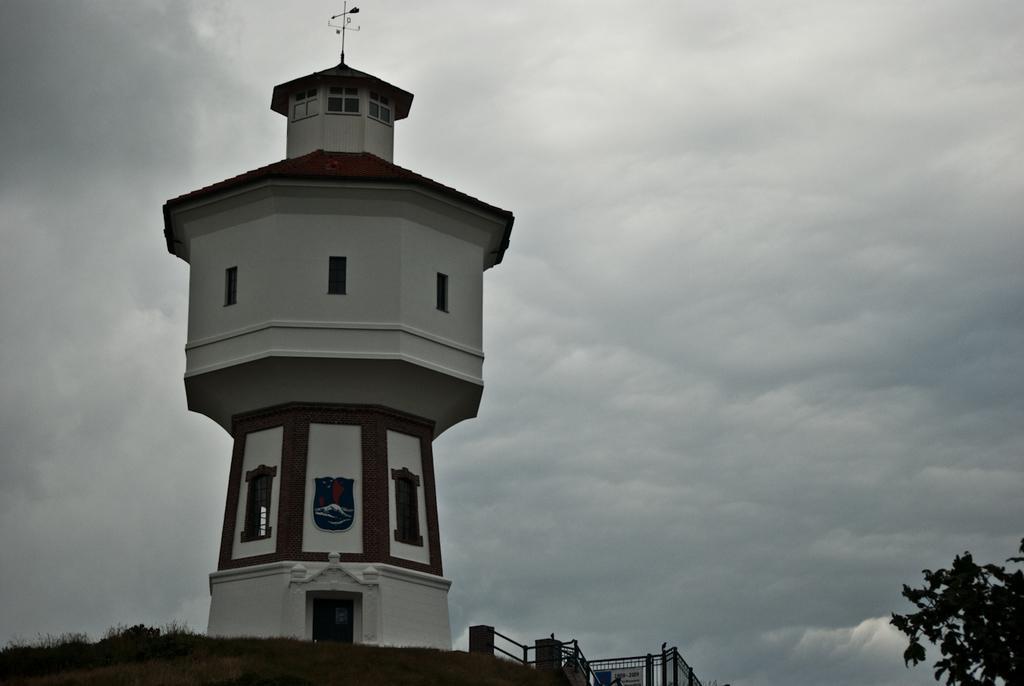Can you describe this image briefly? In this image I can see a building in white and brown color, background I can see planets, and the sky is in white and gray color. 